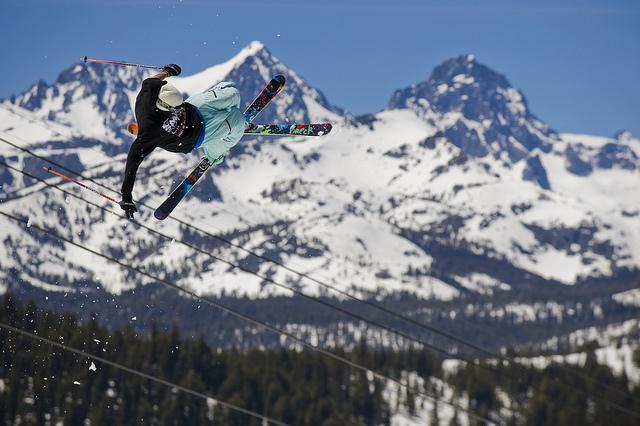How many mountains are in this scene?
Give a very brief answer. 3. 